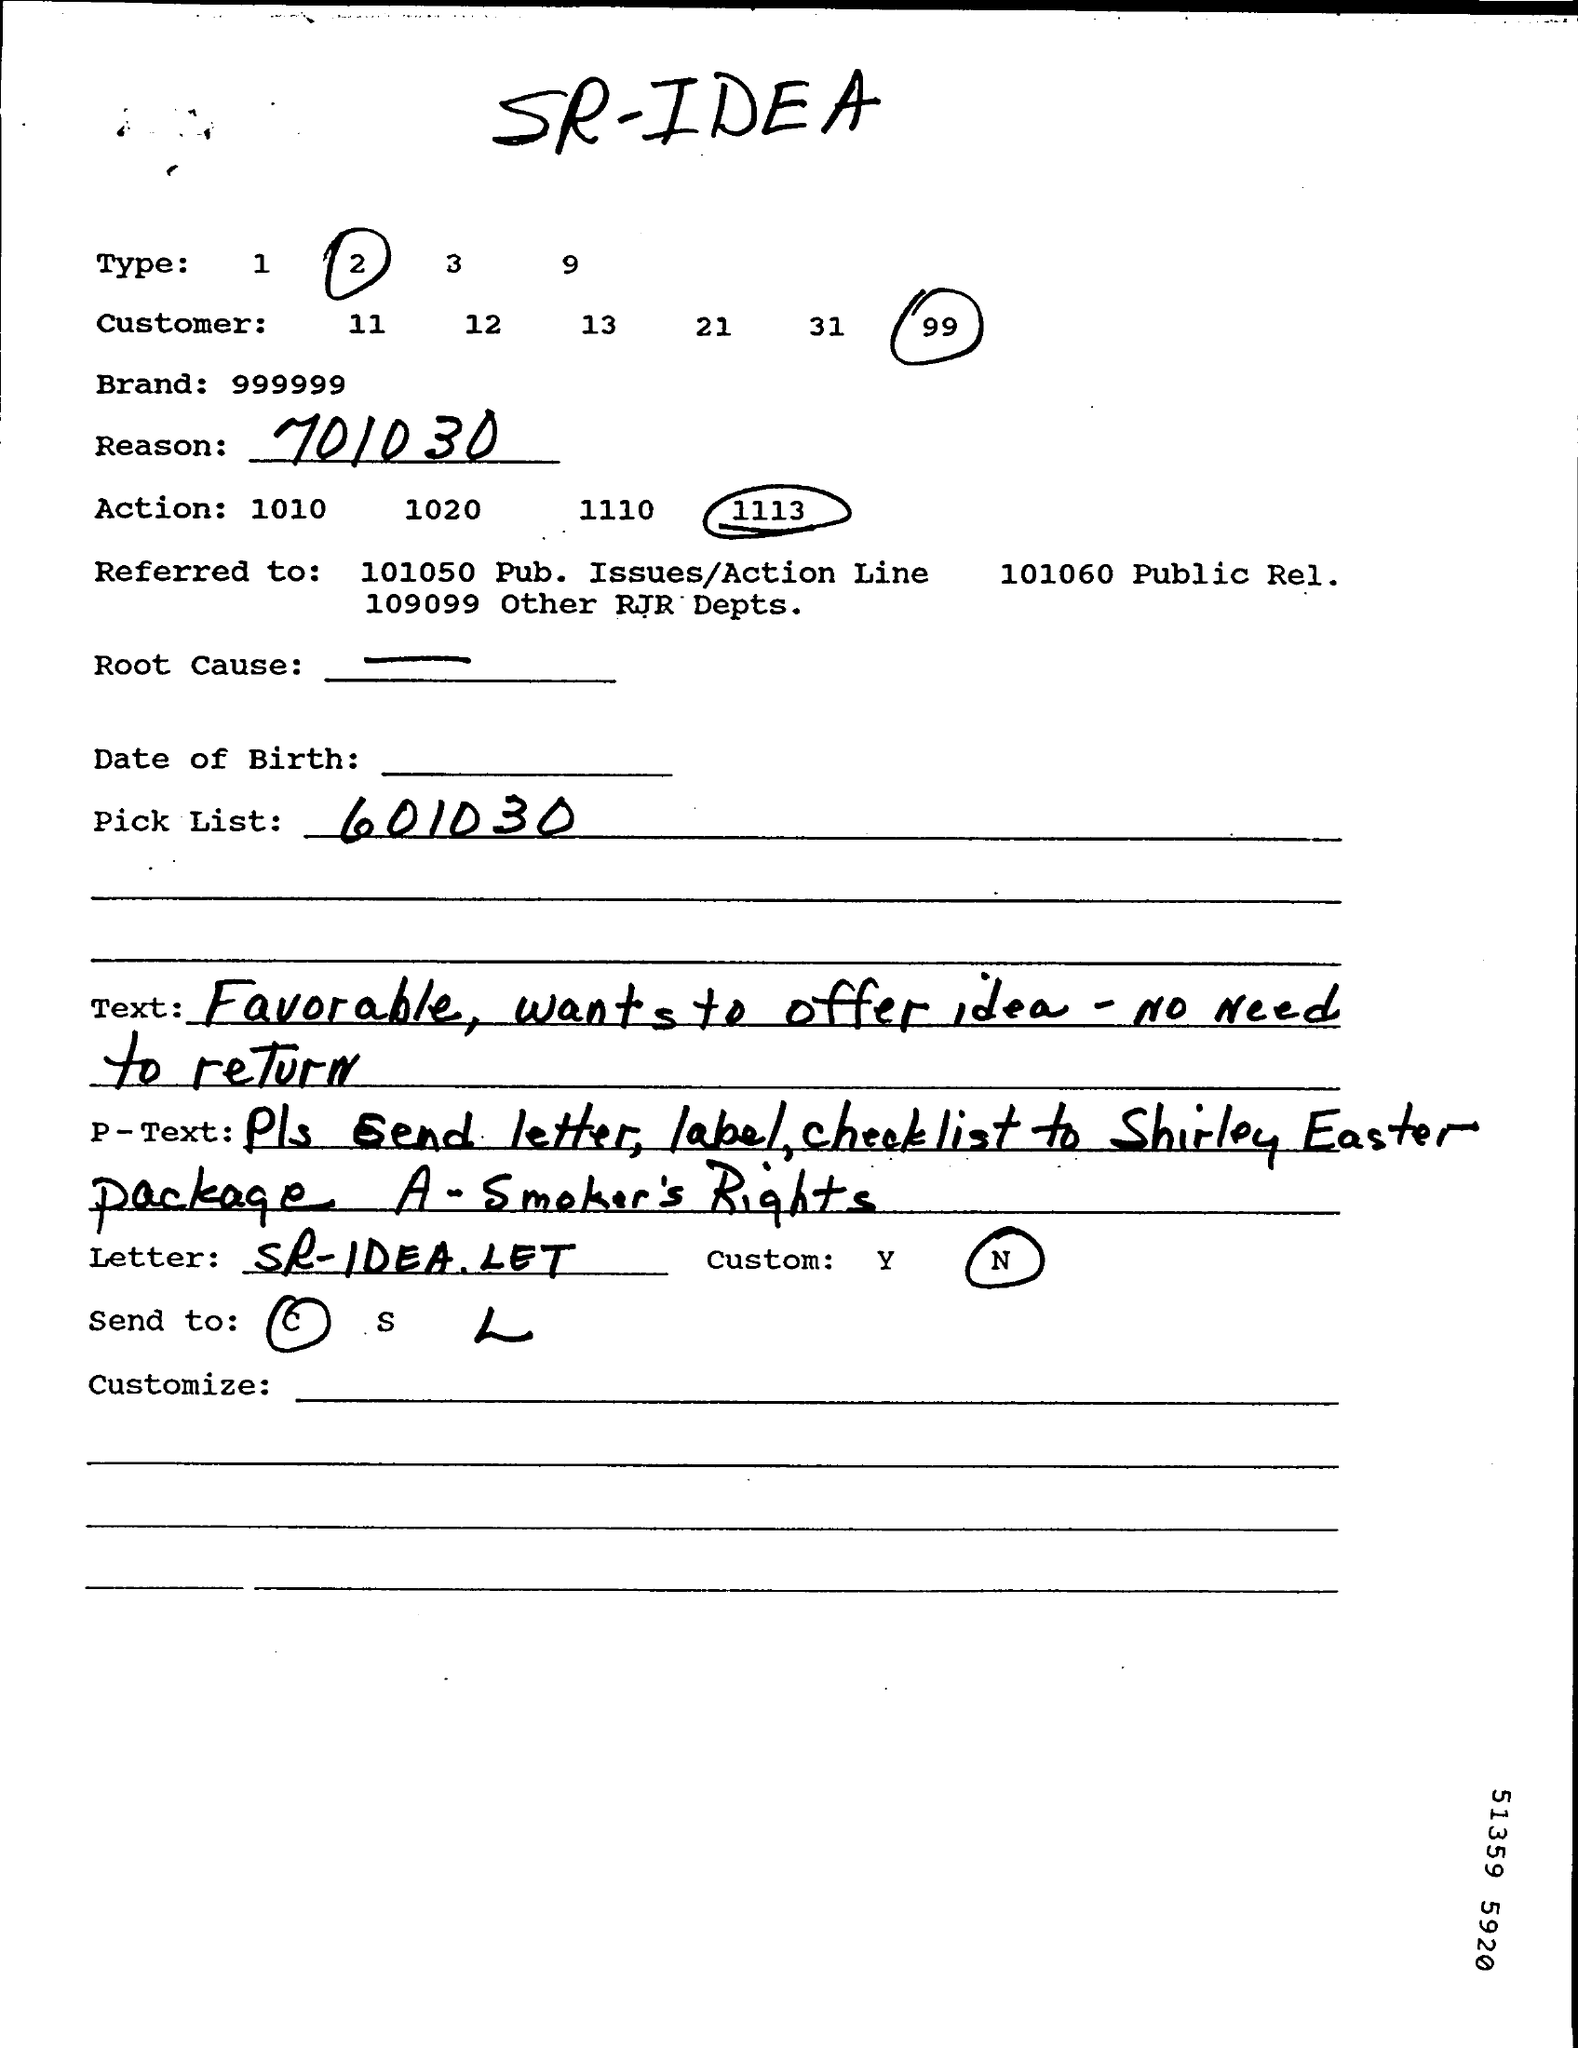What is the Brand?
Provide a short and direct response. 999999. What is the Reason?
Your answer should be very brief. 701030. What is the Pick List?
Provide a succinct answer. 601030. 